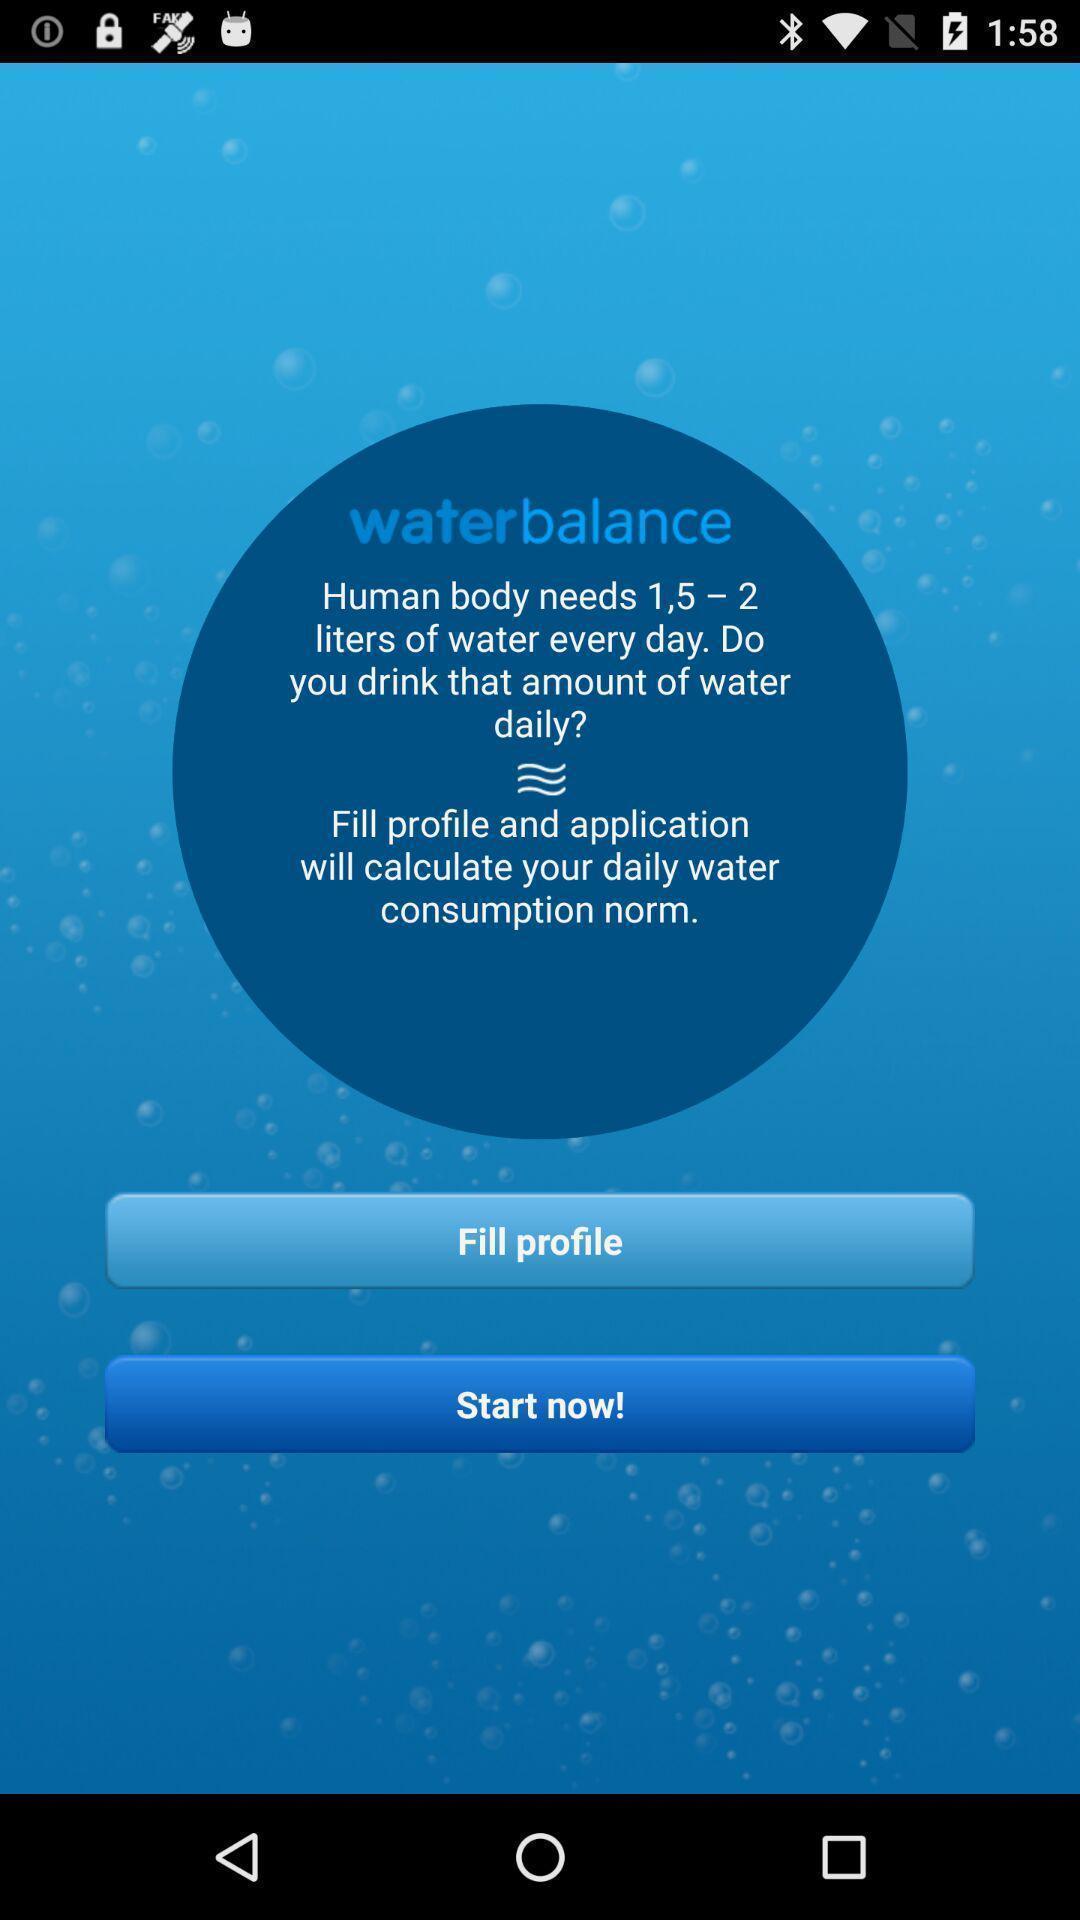Describe the visual elements of this screenshot. Welcome page. 